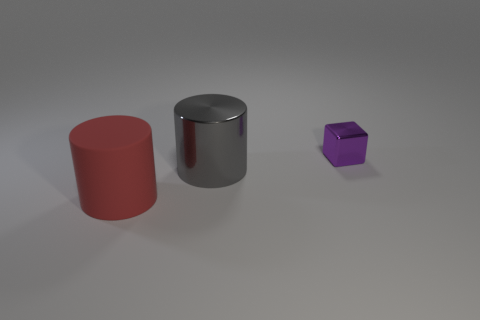Add 1 large gray metallic things. How many objects exist? 4 Subtract all cubes. How many objects are left? 2 Add 1 rubber things. How many rubber things are left? 2 Add 1 small brown rubber things. How many small brown rubber things exist? 1 Subtract 0 brown cylinders. How many objects are left? 3 Subtract all small metal things. Subtract all large gray metallic objects. How many objects are left? 1 